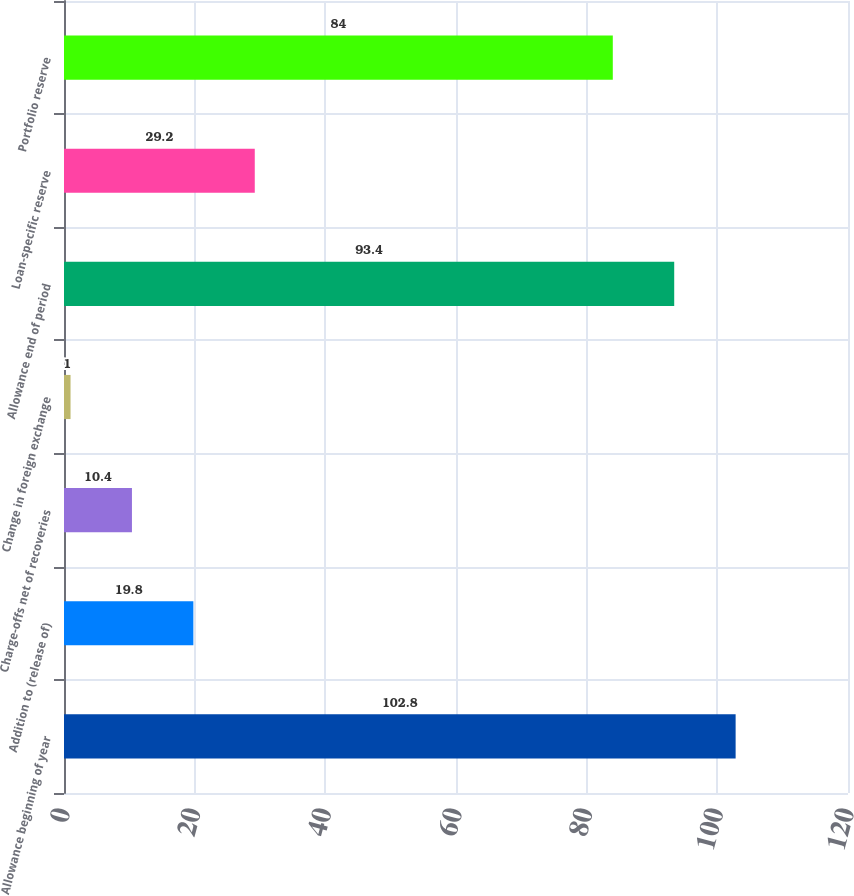Convert chart to OTSL. <chart><loc_0><loc_0><loc_500><loc_500><bar_chart><fcel>Allowance beginning of year<fcel>Addition to (release of)<fcel>Charge-offs net of recoveries<fcel>Change in foreign exchange<fcel>Allowance end of period<fcel>Loan-specific reserve<fcel>Portfolio reserve<nl><fcel>102.8<fcel>19.8<fcel>10.4<fcel>1<fcel>93.4<fcel>29.2<fcel>84<nl></chart> 